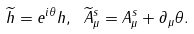<formula> <loc_0><loc_0><loc_500><loc_500>\widetilde { h } = e ^ { i \theta } h , \text { } \widetilde { A } _ { \mu } ^ { s } = A _ { \mu } ^ { s } + \partial _ { \mu } \theta .</formula> 